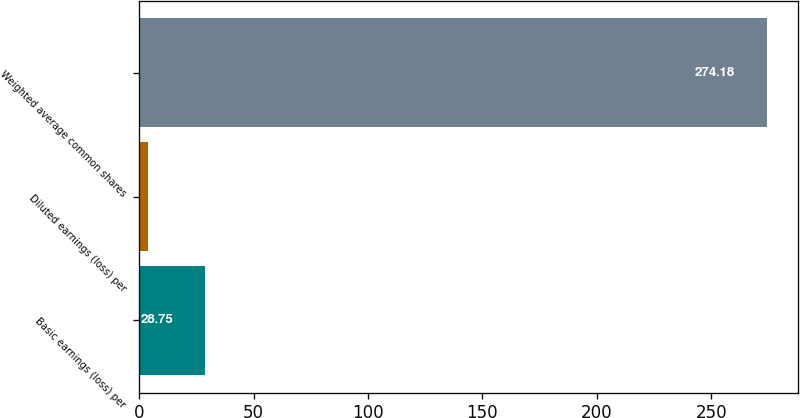Convert chart to OTSL. <chart><loc_0><loc_0><loc_500><loc_500><bar_chart><fcel>Basic earnings (loss) per<fcel>Diluted earnings (loss) per<fcel>Weighted average common shares<nl><fcel>28.75<fcel>3.97<fcel>274.18<nl></chart> 